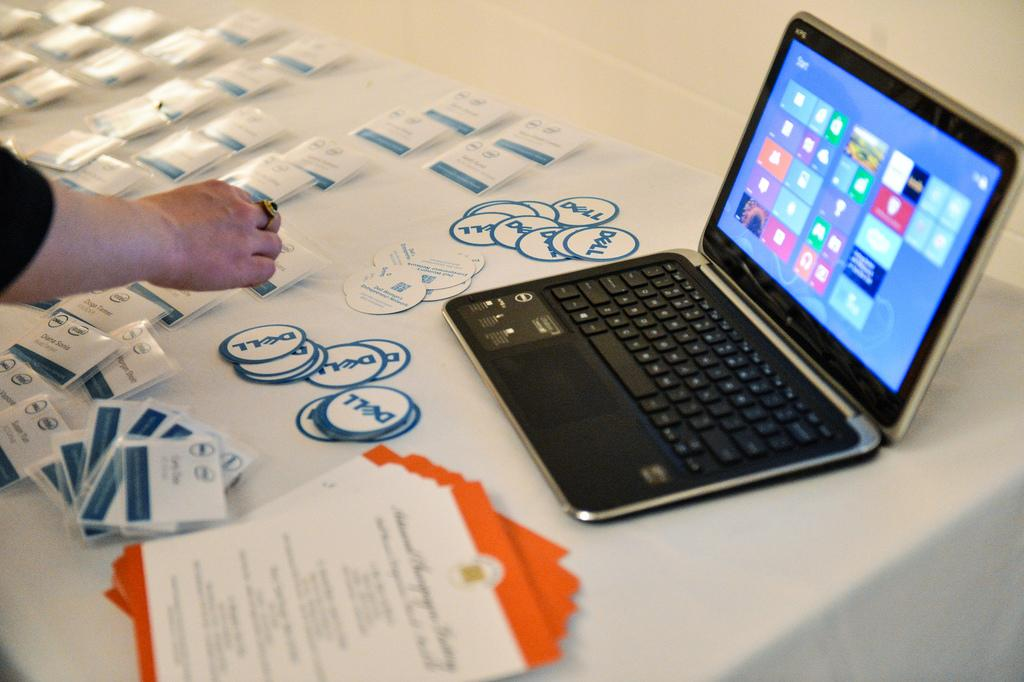<image>
Provide a brief description of the given image. Two stacks of Dell stickers are on a table in front of a laptop. 